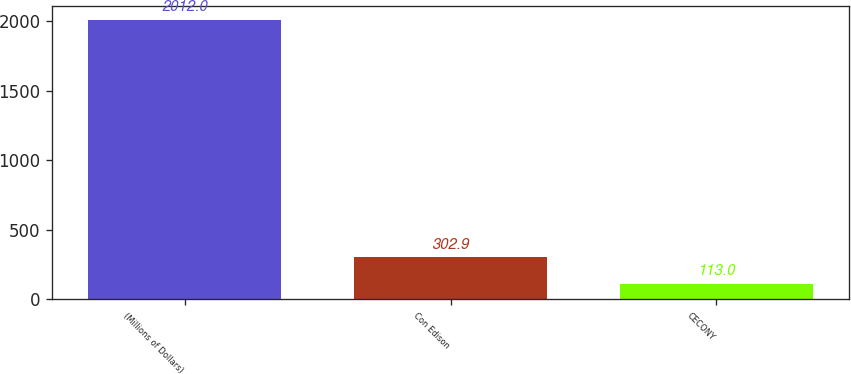<chart> <loc_0><loc_0><loc_500><loc_500><bar_chart><fcel>(Millions of Dollars)<fcel>Con Edison<fcel>CECONY<nl><fcel>2012<fcel>302.9<fcel>113<nl></chart> 